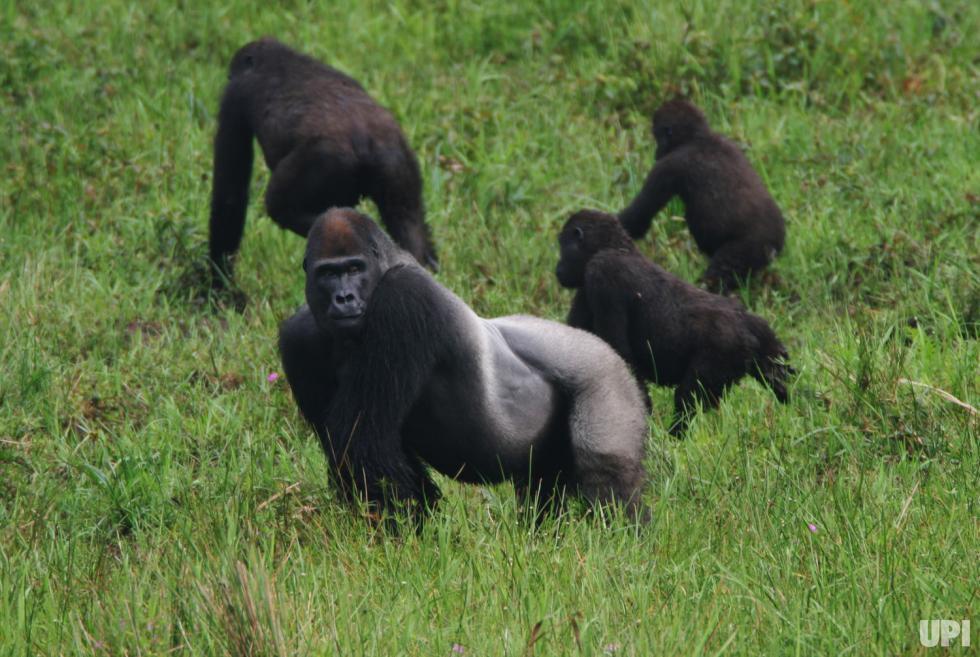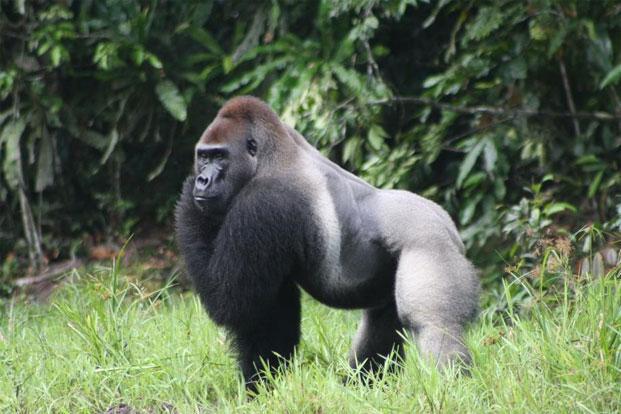The first image is the image on the left, the second image is the image on the right. For the images displayed, is the sentence "Both pictures have an adult gorilla with a young gorilla." factually correct? Answer yes or no. No. The first image is the image on the left, the second image is the image on the right. Given the left and right images, does the statement "Each image features one baby gorilla in contact with one adult gorilla, and one image shows a baby gorilla riding on the back of an adult gorilla." hold true? Answer yes or no. No. 